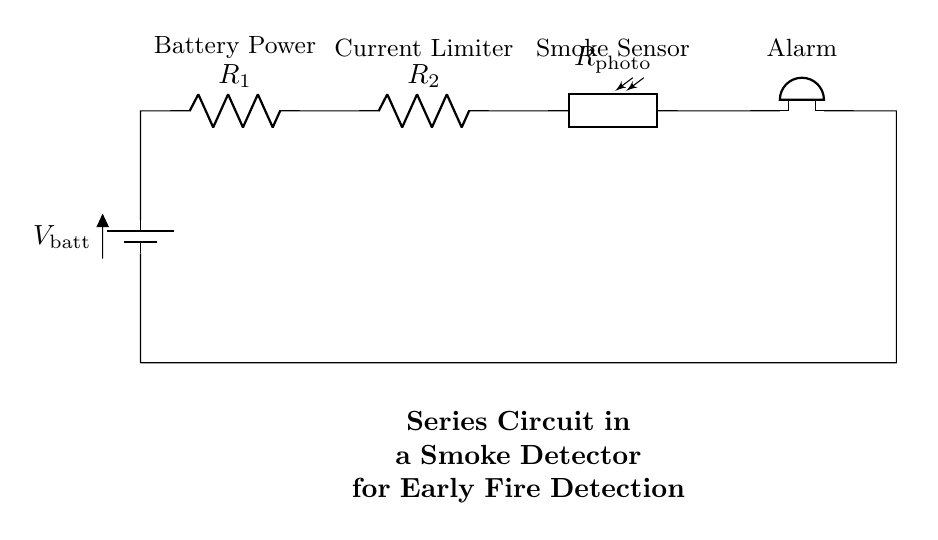What is the role of the battery in this circuit? The battery provides the necessary voltage to power the entire circuit, acting as the energy source for the components.
Answer: energy source What type of component is R2 in this circuit? R2 is a resistor, which is used to limit the current flowing through the circuit, ensuring that the other components receive the appropriate amount of current to function properly.
Answer: resistor How many resistors are present in the circuit? There are two resistors in the circuit, labeled as R1 and R2, each serving to limit the current and protect the other components from overload.
Answer: two What happens if the photoresistor detects smoke? If the photoresistor detects smoke, it will change its resistance, leading to an increase in current which triggers the alarm (buzzer) to sound, indicating the presence of smoke.
Answer: alarm sounds What is the purpose of the buzzer in this circuit? The buzzer serves as an alarm system that alerts occupants of the space when smoke is detected, providing an early warning for fire prevention.
Answer: alert system Which components are arranged in series in this circuit? The components arranged in series are the battery, resistors R1 and R2, the photoresistor, and the buzzer, forming a single pathway for current flow.
Answer: battery, R1, R2, Rphoto, buzzer 